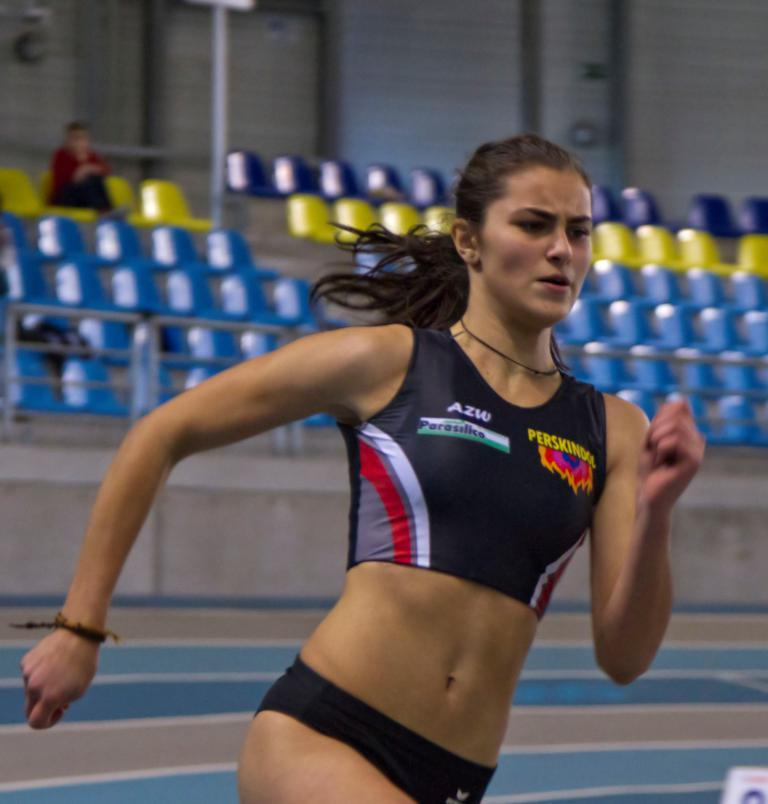<image>
Provide a brief description of the given image. A woman running wearing a shirt that reads Perskindol. 